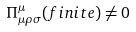<formula> <loc_0><loc_0><loc_500><loc_500>\Pi _ { \mu \rho \sigma } ^ { \mu } ( f i n i t e ) \neq 0</formula> 